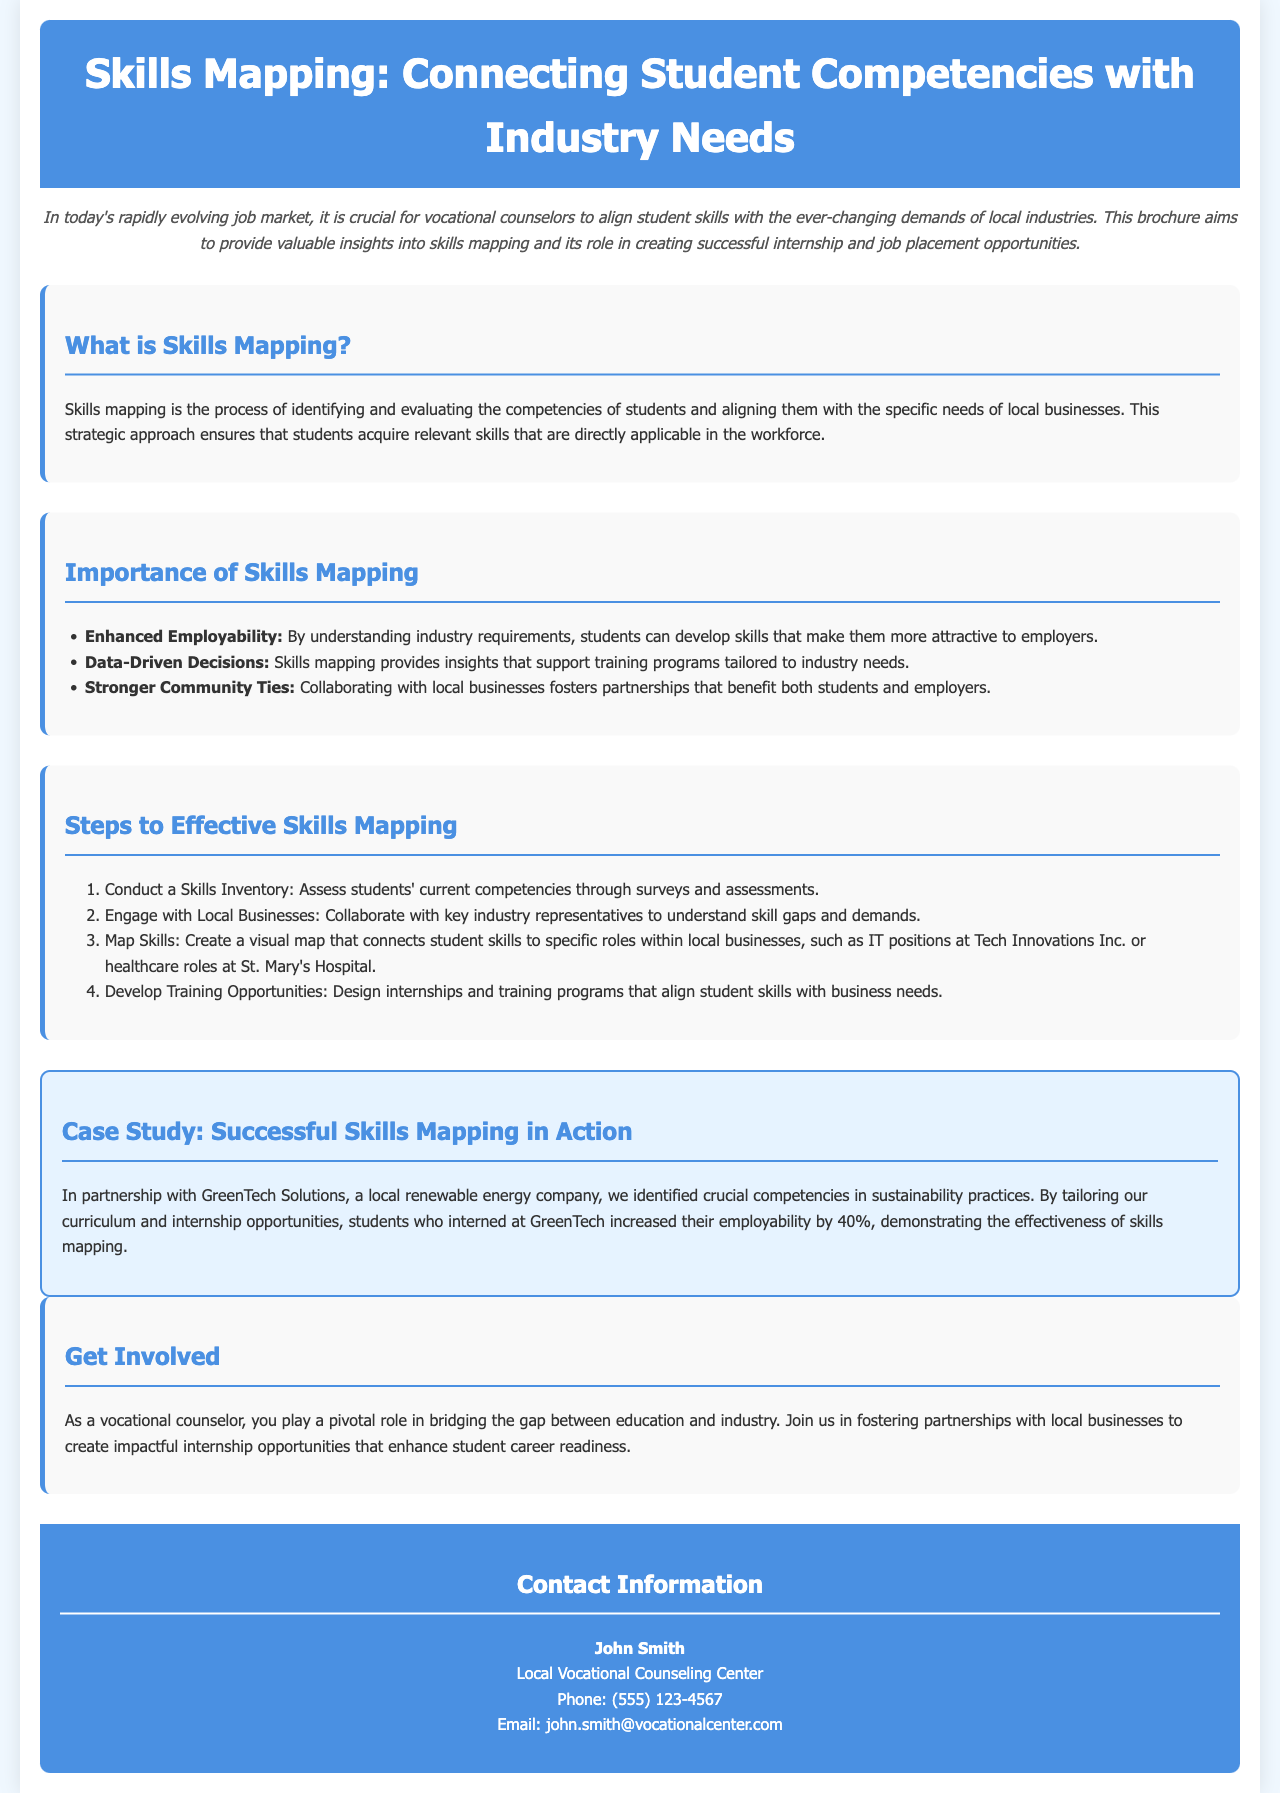What is skills mapping? Skills mapping is the process of identifying and evaluating the competencies of students and aligning them with the specific needs of local businesses.
Answer: Identifying and evaluating competencies What are the three importance points mentioned? The importance section lists three points: Enhanced Employability, Data-Driven Decisions, and Stronger Community Ties.
Answer: Enhanced Employability, Data-Driven Decisions, Stronger Community Ties How many steps are outlined for effective skills mapping? The document lists four steps to effective skills mapping.
Answer: Four Who was the case study partnered with? The case study mentions a partnership with GreenTech Solutions, a local renewable energy company.
Answer: GreenTech Solutions What was the increase in employability for students who interned at GreenTech? The case study states that students who interned increased their employability by 40%.
Answer: 40% What is the name of the contact person listed in the brochure? The contact information section mentions John Smith as the contact person.
Answer: John Smith Which company is mentioned for IT positions? The section on mapping skills references IT positions at Tech Innovations Inc.
Answer: Tech Innovations Inc What type of document is this? This document is designed to provide information and guidance on skills mapping.
Answer: Brochure 